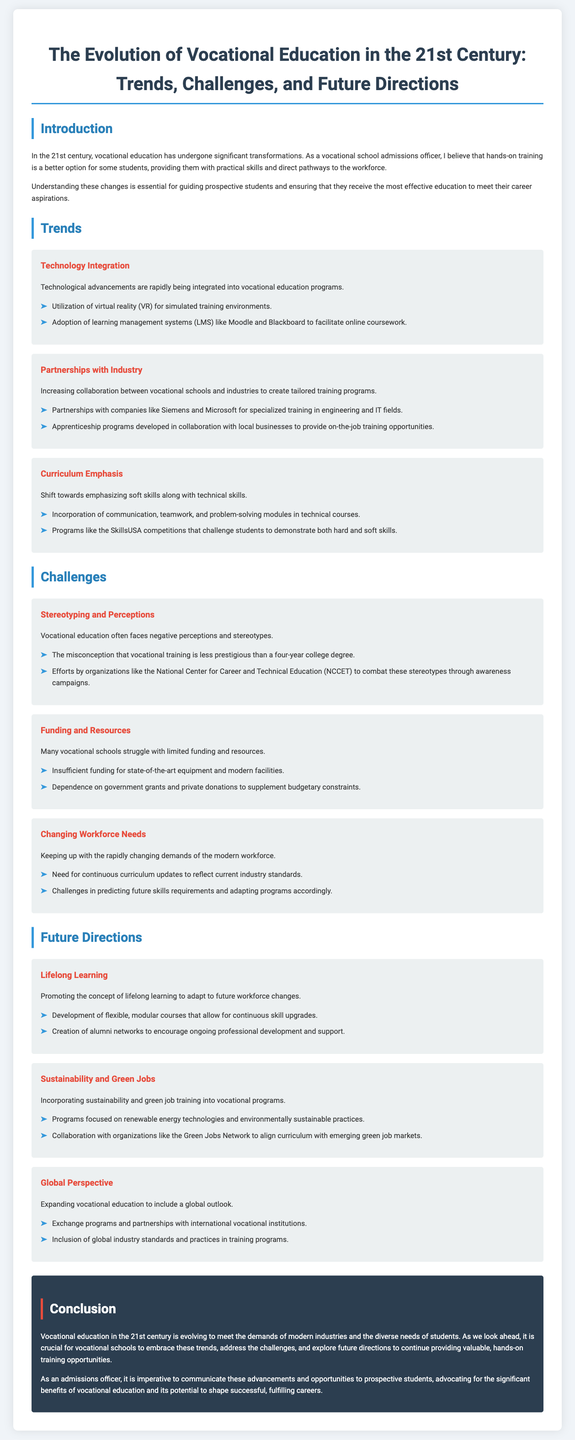What is the focus of the technological advancements in vocational education? The focus is on the integration of virtual reality and learning management systems.
Answer: Technology Integration Who do vocational schools partner with for specialized training in engineering and IT? Vocational schools partner with companies like Siemens and Microsoft.
Answer: Siemens and Microsoft What kind of funding challenges do many vocational schools face? Many vocational schools struggle with limited funding for equipment and facilities.
Answer: Limited funding What skills are emphasized in vocational education alongside technical skills? Soft skills are emphasized alongside technical skills.
Answer: Soft skills What is promoted to adapt to future workforce changes? The concept of lifelong learning is promoted.
Answer: Lifelong learning What type of jobs are vocational programs incorporating training for? Vocational programs are incorporating training for green jobs.
Answer: Green jobs What is a significant negative perception about vocational education? A significant negative perception is that it is less prestigious than a four-year college degree.
Answer: Less prestigious What campaign does NCCET operate to combat negative stereotypes? NCCET operates awareness campaigns.
Answer: Awareness campaigns What do vocational schools need to continuously update in response to workforce changes? They need to continuously update their curriculum.
Answer: Curriculum updates 